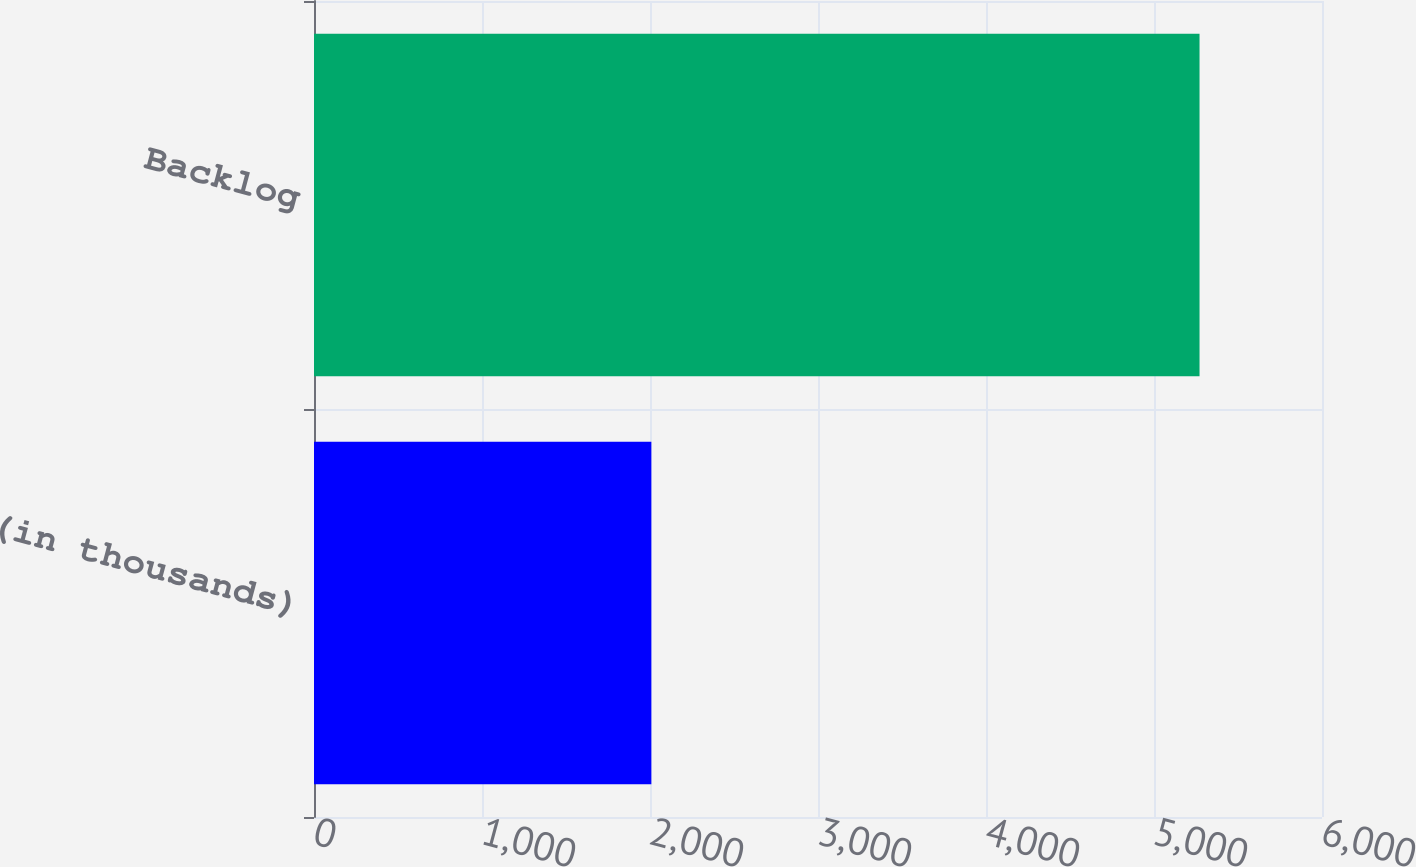Convert chart to OTSL. <chart><loc_0><loc_0><loc_500><loc_500><bar_chart><fcel>(in thousands)<fcel>Backlog<nl><fcel>2008<fcel>5271<nl></chart> 